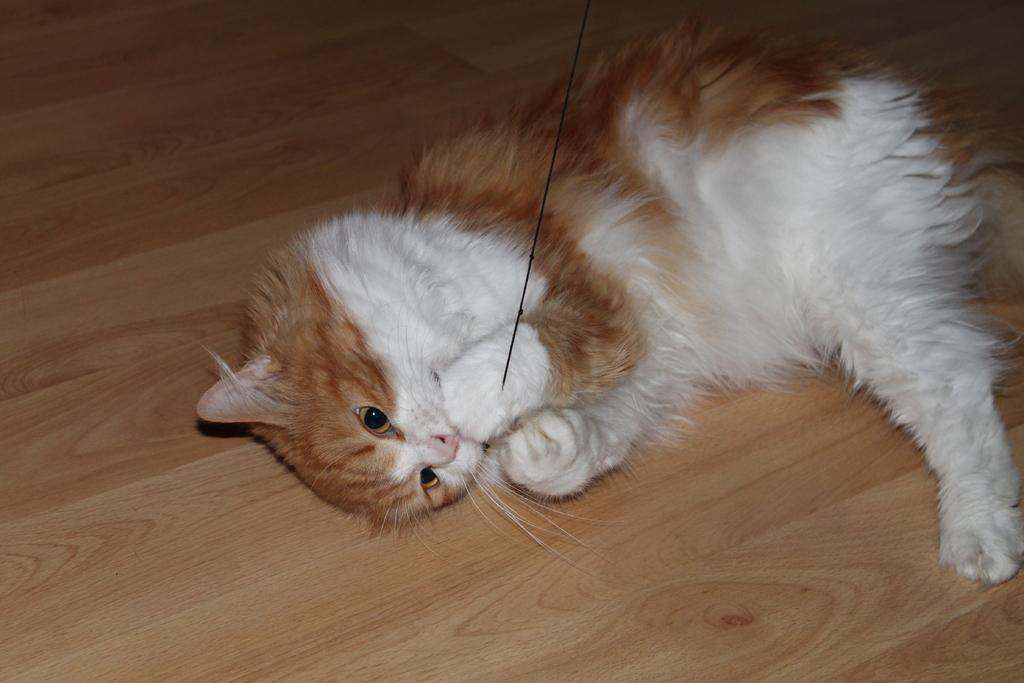What type of animal is in the image? There is a cat in the image. What is the cat doing in the image? The cat is on a surface and holding a thread. What type of boundary can be seen in the image? There is no boundary present in the image; it features a cat on a surface holding a thread. What shapes can be seen in the image? The image does not depict any specific shapes; it features a cat holding a thread. 